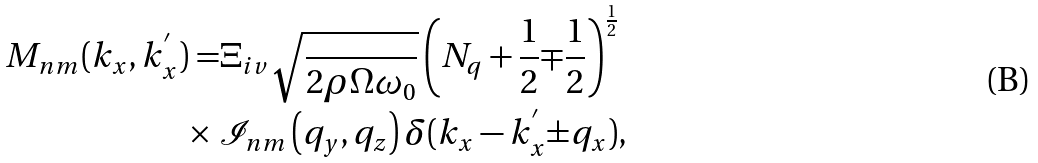Convert formula to latex. <formula><loc_0><loc_0><loc_500><loc_500>M _ { n m } ( k _ { x } , k _ { x } ^ { ^ { \prime } } ) = & \Xi _ { i v } \sqrt { \frac { } { 2 \rho \Omega \omega _ { 0 } } } \left ( N _ { q } + \frac { 1 } { 2 } { \mp } \frac { 1 } { 2 } \right ) ^ { \frac { 1 } { 2 } } \\ \times \ & \mathcal { I } _ { n m } \left ( q _ { y } , q _ { z } \right ) \delta ( k _ { x } - k _ { x } ^ { ^ { \prime } } { \pm } q _ { x } ) ,</formula> 